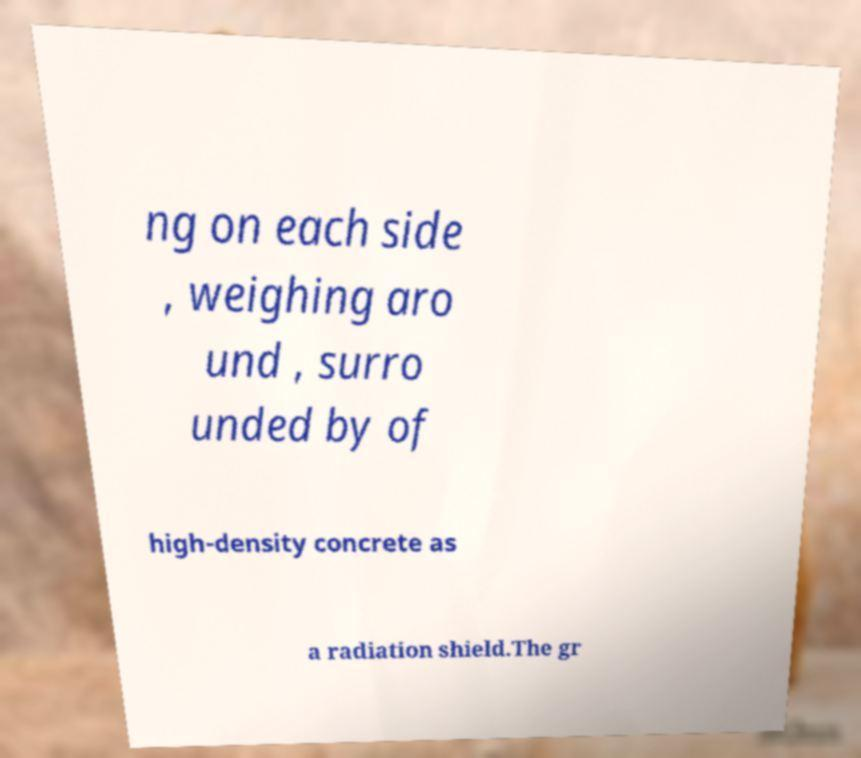Can you read and provide the text displayed in the image?This photo seems to have some interesting text. Can you extract and type it out for me? ng on each side , weighing aro und , surro unded by of high-density concrete as a radiation shield.The gr 